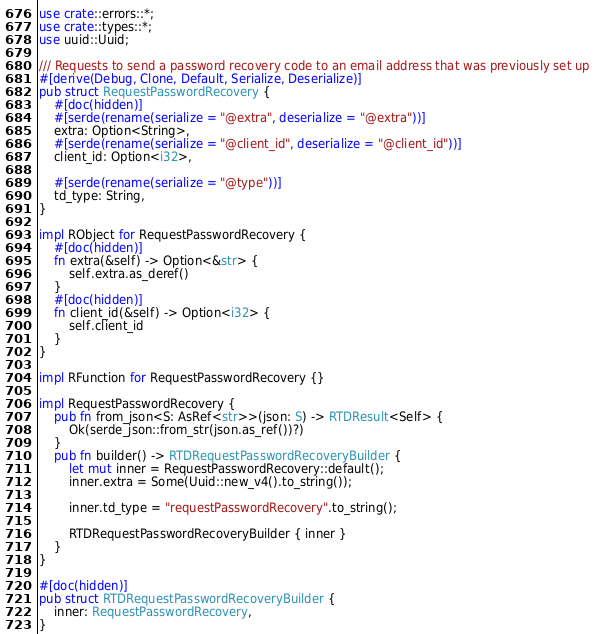<code> <loc_0><loc_0><loc_500><loc_500><_Rust_>use crate::errors::*;
use crate::types::*;
use uuid::Uuid;

/// Requests to send a password recovery code to an email address that was previously set up
#[derive(Debug, Clone, Default, Serialize, Deserialize)]
pub struct RequestPasswordRecovery {
    #[doc(hidden)]
    #[serde(rename(serialize = "@extra", deserialize = "@extra"))]
    extra: Option<String>,
    #[serde(rename(serialize = "@client_id", deserialize = "@client_id"))]
    client_id: Option<i32>,

    #[serde(rename(serialize = "@type"))]
    td_type: String,
}

impl RObject for RequestPasswordRecovery {
    #[doc(hidden)]
    fn extra(&self) -> Option<&str> {
        self.extra.as_deref()
    }
    #[doc(hidden)]
    fn client_id(&self) -> Option<i32> {
        self.client_id
    }
}

impl RFunction for RequestPasswordRecovery {}

impl RequestPasswordRecovery {
    pub fn from_json<S: AsRef<str>>(json: S) -> RTDResult<Self> {
        Ok(serde_json::from_str(json.as_ref())?)
    }
    pub fn builder() -> RTDRequestPasswordRecoveryBuilder {
        let mut inner = RequestPasswordRecovery::default();
        inner.extra = Some(Uuid::new_v4().to_string());

        inner.td_type = "requestPasswordRecovery".to_string();

        RTDRequestPasswordRecoveryBuilder { inner }
    }
}

#[doc(hidden)]
pub struct RTDRequestPasswordRecoveryBuilder {
    inner: RequestPasswordRecovery,
}
</code> 